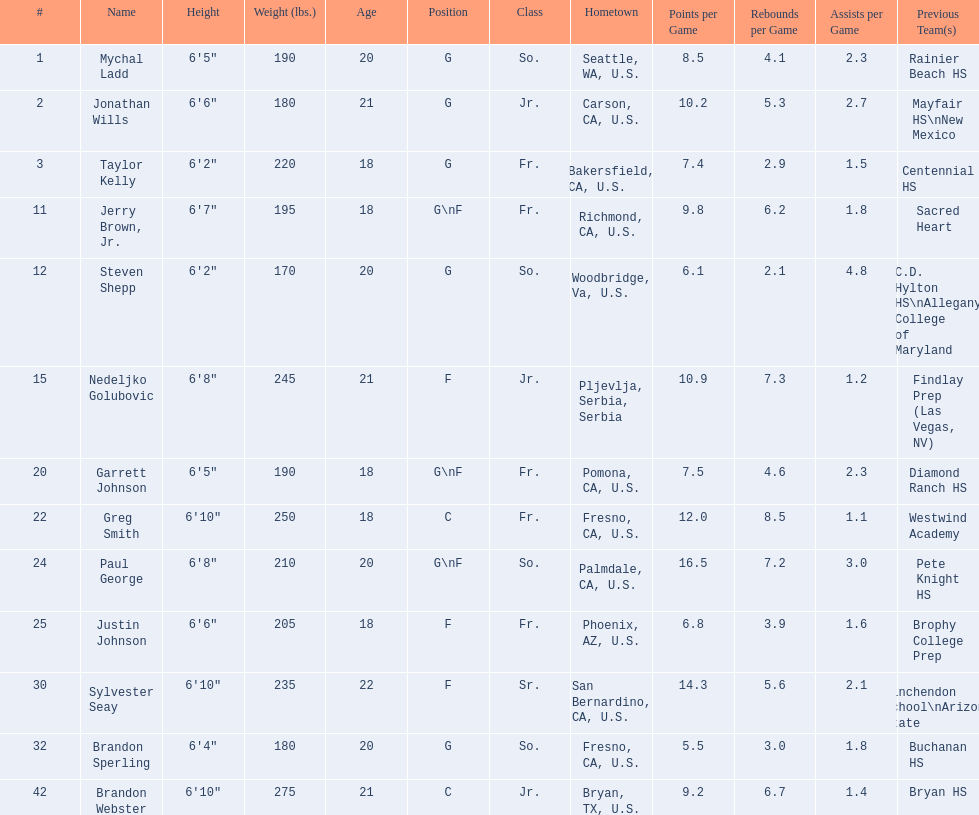Who played during the 2009-10 fresno state bulldogs men's basketball team? Mychal Ladd, Jonathan Wills, Taylor Kelly, Jerry Brown, Jr., Steven Shepp, Nedeljko Golubovic, Garrett Johnson, Greg Smith, Paul George, Justin Johnson, Sylvester Seay, Brandon Sperling, Brandon Webster. What was the position of each player? G, G, G, G\nF, G, F, G\nF, C, G\nF, F, F, G, C. And how tall were they? 6'5", 6'6", 6'2", 6'7", 6'2", 6'8", 6'5", 6'10", 6'8", 6'6", 6'10", 6'4", 6'10". Of these players, who was the shortest forward player? Justin Johnson. 